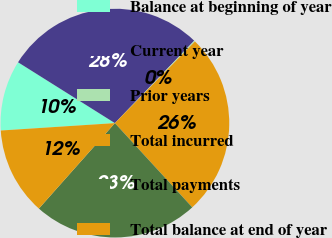<chart> <loc_0><loc_0><loc_500><loc_500><pie_chart><fcel>Balance at beginning of year<fcel>Current year<fcel>Prior years<fcel>Total incurred<fcel>Total payments<fcel>Total balance at end of year<nl><fcel>9.96%<fcel>28.27%<fcel>0.15%<fcel>25.83%<fcel>23.39%<fcel>12.4%<nl></chart> 